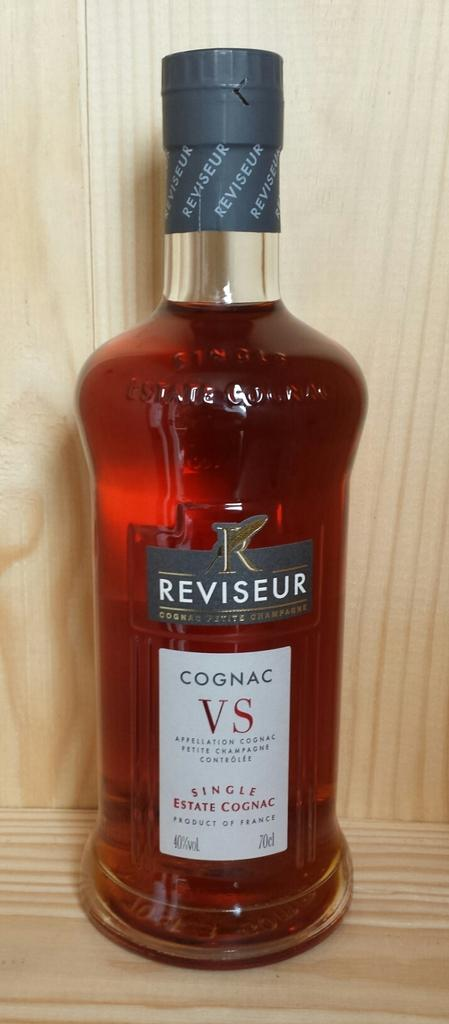<image>
Provide a brief description of the given image. A full bottle of Reviseur Cognac VS Single Estate Cognag. 